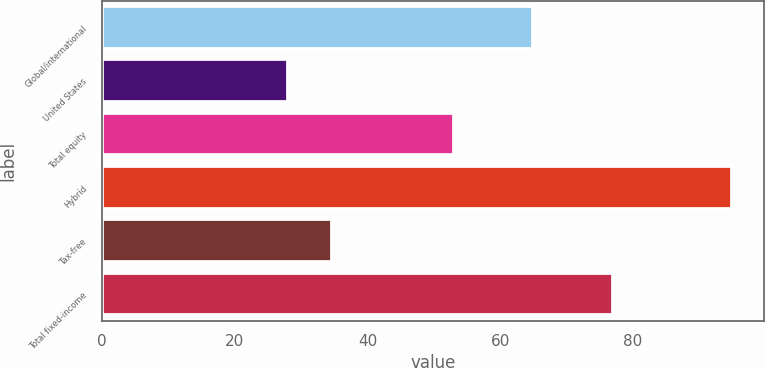<chart> <loc_0><loc_0><loc_500><loc_500><bar_chart><fcel>Global/international<fcel>United States<fcel>Total equity<fcel>Hybrid<fcel>Tax-free<fcel>Total fixed-income<nl><fcel>65<fcel>28<fcel>53<fcel>95<fcel>34.7<fcel>77<nl></chart> 